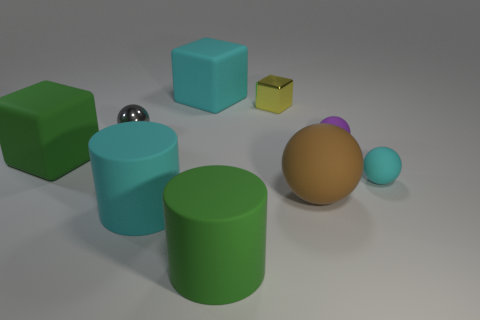Subtract all purple rubber balls. How many balls are left? 3 Subtract 3 balls. How many balls are left? 1 Subtract all cyan cubes. How many cubes are left? 2 Subtract all cylinders. How many objects are left? 7 Add 4 big rubber spheres. How many big rubber spheres are left? 5 Add 6 tiny cyan spheres. How many tiny cyan spheres exist? 7 Subtract 0 purple cylinders. How many objects are left? 9 Subtract all green blocks. Subtract all brown spheres. How many blocks are left? 2 Subtract all yellow cylinders. How many yellow blocks are left? 1 Subtract all cyan matte spheres. Subtract all green cylinders. How many objects are left? 7 